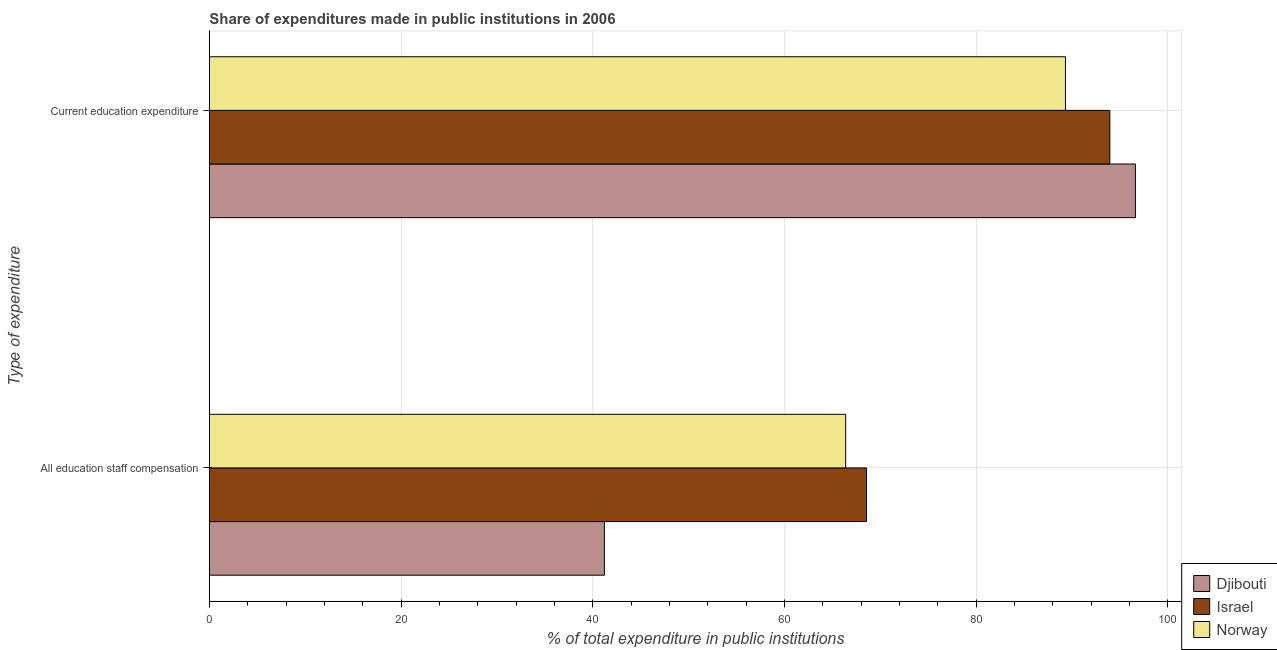How many different coloured bars are there?
Your response must be concise. 3. How many groups of bars are there?
Your answer should be very brief. 2. Are the number of bars per tick equal to the number of legend labels?
Your answer should be very brief. Yes. Are the number of bars on each tick of the Y-axis equal?
Give a very brief answer. Yes. What is the label of the 1st group of bars from the top?
Offer a very short reply. Current education expenditure. What is the expenditure in staff compensation in Israel?
Provide a succinct answer. 68.56. Across all countries, what is the maximum expenditure in staff compensation?
Ensure brevity in your answer.  68.56. Across all countries, what is the minimum expenditure in staff compensation?
Provide a short and direct response. 41.21. In which country was the expenditure in education maximum?
Ensure brevity in your answer.  Djibouti. In which country was the expenditure in staff compensation minimum?
Offer a very short reply. Djibouti. What is the total expenditure in staff compensation in the graph?
Ensure brevity in your answer.  176.16. What is the difference between the expenditure in staff compensation in Israel and that in Djibouti?
Offer a terse response. 27.35. What is the difference between the expenditure in education in Norway and the expenditure in staff compensation in Israel?
Give a very brief answer. 20.76. What is the average expenditure in staff compensation per country?
Your answer should be very brief. 58.72. What is the difference between the expenditure in education and expenditure in staff compensation in Djibouti?
Provide a short and direct response. 55.41. What is the ratio of the expenditure in staff compensation in Israel to that in Norway?
Ensure brevity in your answer.  1.03. What does the 1st bar from the top in Current education expenditure represents?
Ensure brevity in your answer.  Norway. How many bars are there?
Offer a very short reply. 6. Are all the bars in the graph horizontal?
Keep it short and to the point. Yes. How many countries are there in the graph?
Provide a short and direct response. 3. Does the graph contain any zero values?
Your answer should be compact. No. Does the graph contain grids?
Offer a very short reply. Yes. Where does the legend appear in the graph?
Give a very brief answer. Bottom right. How are the legend labels stacked?
Give a very brief answer. Vertical. What is the title of the graph?
Make the answer very short. Share of expenditures made in public institutions in 2006. What is the label or title of the X-axis?
Make the answer very short. % of total expenditure in public institutions. What is the label or title of the Y-axis?
Your answer should be compact. Type of expenditure. What is the % of total expenditure in public institutions in Djibouti in All education staff compensation?
Keep it short and to the point. 41.21. What is the % of total expenditure in public institutions in Israel in All education staff compensation?
Give a very brief answer. 68.56. What is the % of total expenditure in public institutions in Norway in All education staff compensation?
Your response must be concise. 66.39. What is the % of total expenditure in public institutions in Djibouti in Current education expenditure?
Provide a short and direct response. 96.62. What is the % of total expenditure in public institutions of Israel in Current education expenditure?
Offer a very short reply. 93.95. What is the % of total expenditure in public institutions of Norway in Current education expenditure?
Provide a succinct answer. 89.33. Across all Type of expenditure, what is the maximum % of total expenditure in public institutions in Djibouti?
Provide a short and direct response. 96.62. Across all Type of expenditure, what is the maximum % of total expenditure in public institutions of Israel?
Your answer should be compact. 93.95. Across all Type of expenditure, what is the maximum % of total expenditure in public institutions in Norway?
Offer a terse response. 89.33. Across all Type of expenditure, what is the minimum % of total expenditure in public institutions in Djibouti?
Provide a short and direct response. 41.21. Across all Type of expenditure, what is the minimum % of total expenditure in public institutions in Israel?
Offer a very short reply. 68.56. Across all Type of expenditure, what is the minimum % of total expenditure in public institutions of Norway?
Provide a short and direct response. 66.39. What is the total % of total expenditure in public institutions in Djibouti in the graph?
Offer a very short reply. 137.84. What is the total % of total expenditure in public institutions in Israel in the graph?
Offer a very short reply. 162.52. What is the total % of total expenditure in public institutions in Norway in the graph?
Make the answer very short. 155.72. What is the difference between the % of total expenditure in public institutions of Djibouti in All education staff compensation and that in Current education expenditure?
Your answer should be very brief. -55.41. What is the difference between the % of total expenditure in public institutions in Israel in All education staff compensation and that in Current education expenditure?
Your answer should be very brief. -25.39. What is the difference between the % of total expenditure in public institutions in Norway in All education staff compensation and that in Current education expenditure?
Provide a succinct answer. -22.94. What is the difference between the % of total expenditure in public institutions of Djibouti in All education staff compensation and the % of total expenditure in public institutions of Israel in Current education expenditure?
Ensure brevity in your answer.  -52.74. What is the difference between the % of total expenditure in public institutions of Djibouti in All education staff compensation and the % of total expenditure in public institutions of Norway in Current education expenditure?
Provide a short and direct response. -48.11. What is the difference between the % of total expenditure in public institutions of Israel in All education staff compensation and the % of total expenditure in public institutions of Norway in Current education expenditure?
Provide a succinct answer. -20.76. What is the average % of total expenditure in public institutions of Djibouti per Type of expenditure?
Ensure brevity in your answer.  68.92. What is the average % of total expenditure in public institutions in Israel per Type of expenditure?
Ensure brevity in your answer.  81.26. What is the average % of total expenditure in public institutions of Norway per Type of expenditure?
Keep it short and to the point. 77.86. What is the difference between the % of total expenditure in public institutions of Djibouti and % of total expenditure in public institutions of Israel in All education staff compensation?
Provide a succinct answer. -27.35. What is the difference between the % of total expenditure in public institutions of Djibouti and % of total expenditure in public institutions of Norway in All education staff compensation?
Offer a terse response. -25.18. What is the difference between the % of total expenditure in public institutions in Israel and % of total expenditure in public institutions in Norway in All education staff compensation?
Ensure brevity in your answer.  2.17. What is the difference between the % of total expenditure in public institutions of Djibouti and % of total expenditure in public institutions of Israel in Current education expenditure?
Provide a short and direct response. 2.67. What is the difference between the % of total expenditure in public institutions of Djibouti and % of total expenditure in public institutions of Norway in Current education expenditure?
Provide a succinct answer. 7.3. What is the difference between the % of total expenditure in public institutions in Israel and % of total expenditure in public institutions in Norway in Current education expenditure?
Offer a terse response. 4.63. What is the ratio of the % of total expenditure in public institutions in Djibouti in All education staff compensation to that in Current education expenditure?
Your answer should be very brief. 0.43. What is the ratio of the % of total expenditure in public institutions of Israel in All education staff compensation to that in Current education expenditure?
Your answer should be compact. 0.73. What is the ratio of the % of total expenditure in public institutions of Norway in All education staff compensation to that in Current education expenditure?
Keep it short and to the point. 0.74. What is the difference between the highest and the second highest % of total expenditure in public institutions in Djibouti?
Offer a terse response. 55.41. What is the difference between the highest and the second highest % of total expenditure in public institutions of Israel?
Your response must be concise. 25.39. What is the difference between the highest and the second highest % of total expenditure in public institutions in Norway?
Your answer should be very brief. 22.94. What is the difference between the highest and the lowest % of total expenditure in public institutions of Djibouti?
Provide a short and direct response. 55.41. What is the difference between the highest and the lowest % of total expenditure in public institutions of Israel?
Your answer should be very brief. 25.39. What is the difference between the highest and the lowest % of total expenditure in public institutions of Norway?
Make the answer very short. 22.94. 